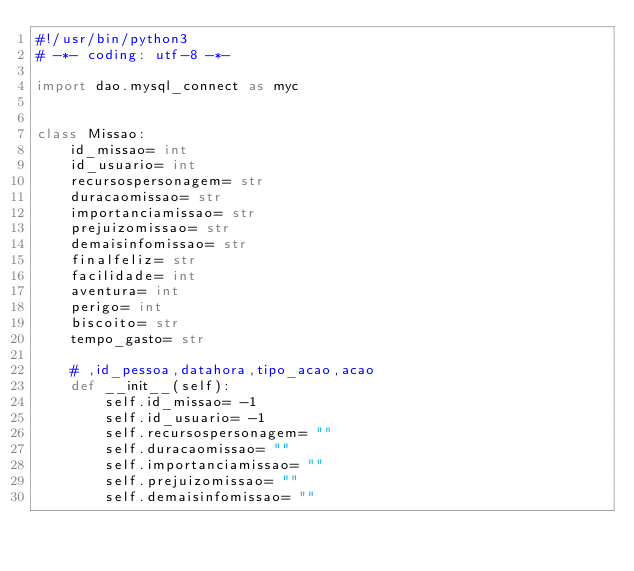<code> <loc_0><loc_0><loc_500><loc_500><_Python_>#!/usr/bin/python3
# -*- coding: utf-8 -*-

import dao.mysql_connect as myc


class Missao:
    id_missao= int
    id_usuario= int
    recursospersonagem= str
    duracaomissao= str
    importanciamissao= str
    prejuizomissao= str
    demaisinfomissao= str
    finalfeliz= str
    facilidade= int
    aventura= int
    perigo= int
    biscoito= str
    tempo_gasto= str

    # ,id_pessoa,datahora,tipo_acao,acao
    def __init__(self):
        self.id_missao= -1
        self.id_usuario= -1
        self.recursospersonagem= ""
        self.duracaomissao= ""
        self.importanciamissao= ""
        self.prejuizomissao= ""
        self.demaisinfomissao= ""</code> 